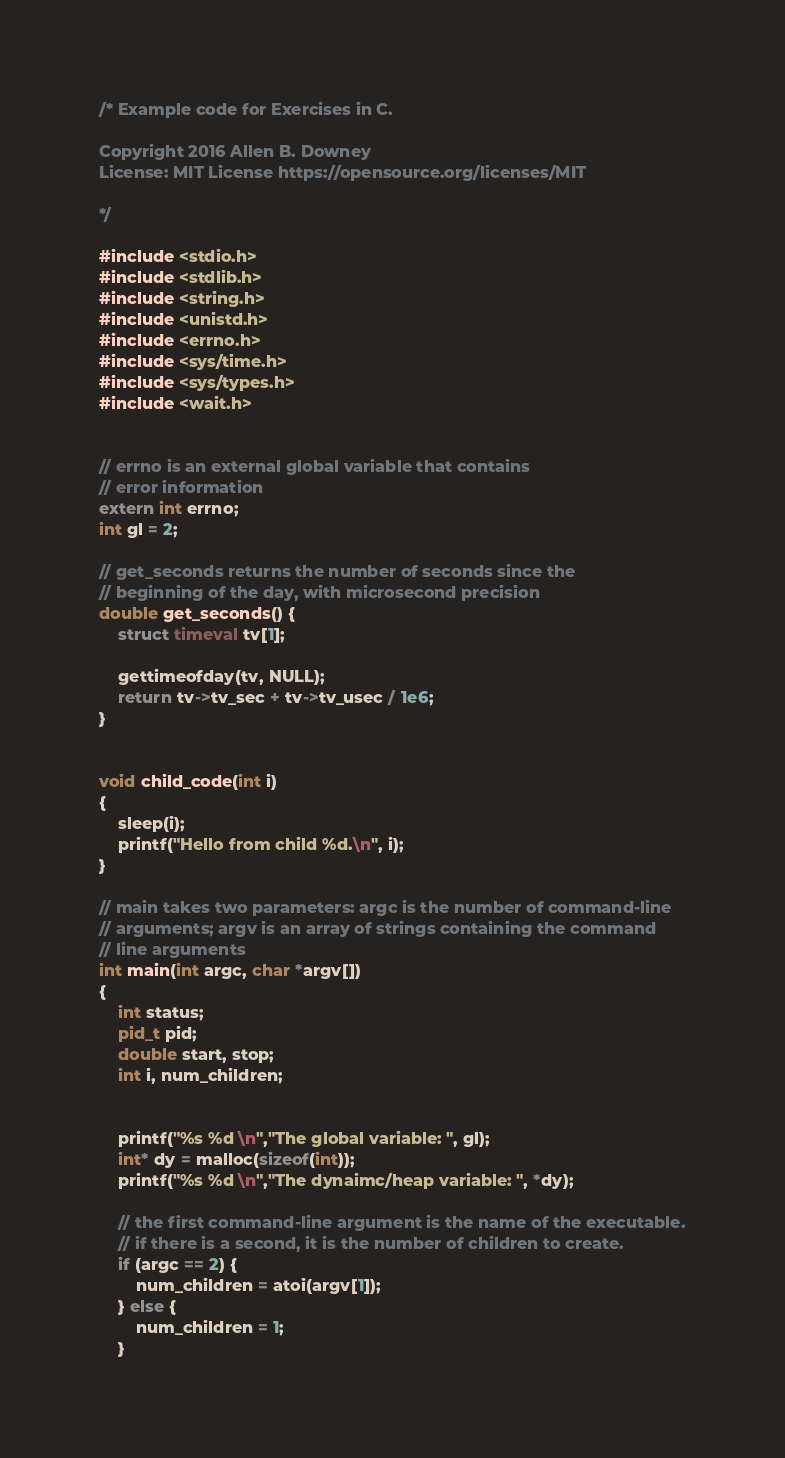Convert code to text. <code><loc_0><loc_0><loc_500><loc_500><_C_>/* Example code for Exercises in C.

Copyright 2016 Allen B. Downey
License: MIT License https://opensource.org/licenses/MIT

*/

#include <stdio.h>
#include <stdlib.h>
#include <string.h>
#include <unistd.h>
#include <errno.h>
#include <sys/time.h>
#include <sys/types.h>
#include <wait.h>


// errno is an external global variable that contains
// error information
extern int errno;
int gl = 2;

// get_seconds returns the number of seconds since the
// beginning of the day, with microsecond precision
double get_seconds() {
    struct timeval tv[1];

    gettimeofday(tv, NULL);
    return tv->tv_sec + tv->tv_usec / 1e6;
}


void child_code(int i)
{
    sleep(i);
    printf("Hello from child %d.\n", i);
}

// main takes two parameters: argc is the number of command-line
// arguments; argv is an array of strings containing the command
// line arguments
int main(int argc, char *argv[])
{
    int status;
    pid_t pid;
    double start, stop;
    int i, num_children;


    printf("%s %d \n","The global variable: ", gl);
    int* dy = malloc(sizeof(int));
    printf("%s %d \n","The dynaimc/heap variable: ", *dy);

    // the first command-line argument is the name of the executable.
    // if there is a second, it is the number of children to create.
    if (argc == 2) {
        num_children = atoi(argv[1]);
    } else {
        num_children = 1;
    }
</code> 